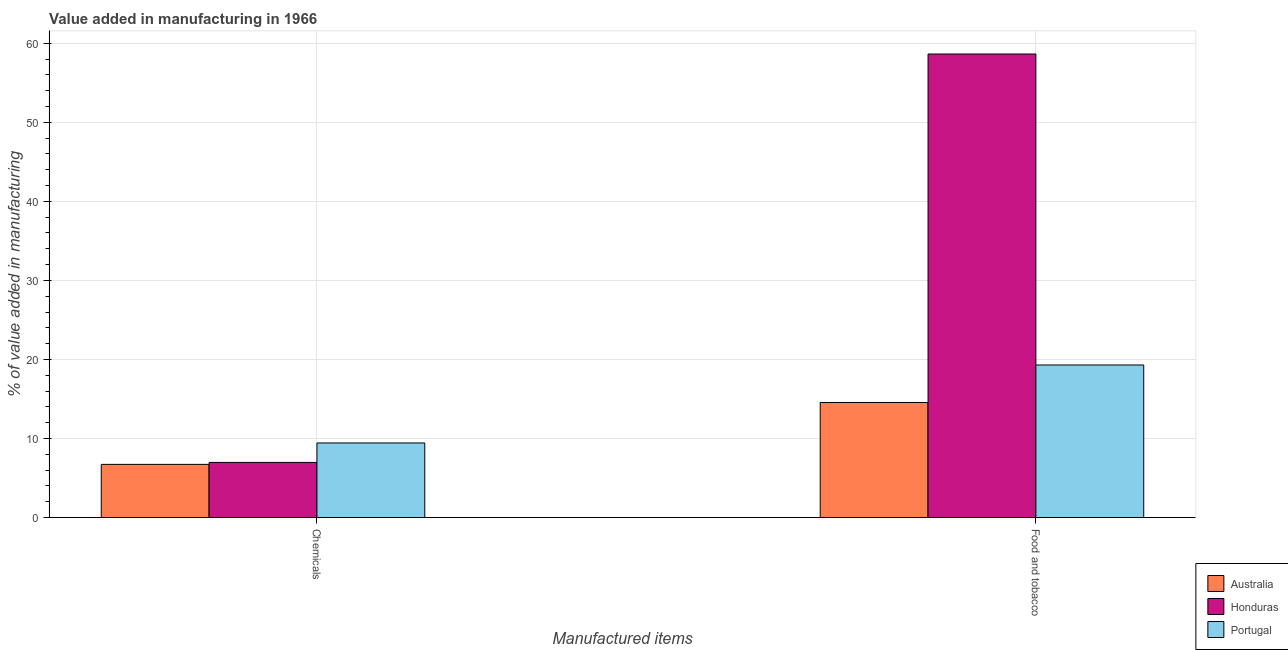How many groups of bars are there?
Keep it short and to the point. 2. How many bars are there on the 1st tick from the right?
Your response must be concise. 3. What is the label of the 1st group of bars from the left?
Offer a terse response. Chemicals. What is the value added by manufacturing food and tobacco in Australia?
Give a very brief answer. 14.56. Across all countries, what is the maximum value added by  manufacturing chemicals?
Offer a terse response. 9.44. Across all countries, what is the minimum value added by  manufacturing chemicals?
Make the answer very short. 6.73. What is the total value added by manufacturing food and tobacco in the graph?
Your answer should be compact. 92.49. What is the difference between the value added by manufacturing food and tobacco in Honduras and that in Portugal?
Your answer should be compact. 39.34. What is the difference between the value added by  manufacturing chemicals in Honduras and the value added by manufacturing food and tobacco in Portugal?
Offer a terse response. -12.33. What is the average value added by  manufacturing chemicals per country?
Make the answer very short. 7.71. What is the difference between the value added by  manufacturing chemicals and value added by manufacturing food and tobacco in Australia?
Ensure brevity in your answer.  -7.83. In how many countries, is the value added by  manufacturing chemicals greater than 46 %?
Give a very brief answer. 0. What is the ratio of the value added by  manufacturing chemicals in Portugal to that in Honduras?
Give a very brief answer. 1.35. What does the 2nd bar from the left in Food and tobacco represents?
Offer a very short reply. Honduras. What does the 2nd bar from the right in Food and tobacco represents?
Provide a succinct answer. Honduras. How many bars are there?
Make the answer very short. 6. Are all the bars in the graph horizontal?
Give a very brief answer. No. How many countries are there in the graph?
Make the answer very short. 3. What is the difference between two consecutive major ticks on the Y-axis?
Ensure brevity in your answer.  10. How many legend labels are there?
Your answer should be compact. 3. What is the title of the graph?
Your response must be concise. Value added in manufacturing in 1966. Does "Micronesia" appear as one of the legend labels in the graph?
Provide a short and direct response. No. What is the label or title of the X-axis?
Offer a terse response. Manufactured items. What is the label or title of the Y-axis?
Give a very brief answer. % of value added in manufacturing. What is the % of value added in manufacturing of Australia in Chemicals?
Offer a terse response. 6.73. What is the % of value added in manufacturing in Honduras in Chemicals?
Your answer should be very brief. 6.97. What is the % of value added in manufacturing in Portugal in Chemicals?
Provide a succinct answer. 9.44. What is the % of value added in manufacturing in Australia in Food and tobacco?
Ensure brevity in your answer.  14.56. What is the % of value added in manufacturing in Honduras in Food and tobacco?
Your answer should be compact. 58.64. What is the % of value added in manufacturing of Portugal in Food and tobacco?
Offer a terse response. 19.3. Across all Manufactured items, what is the maximum % of value added in manufacturing in Australia?
Give a very brief answer. 14.56. Across all Manufactured items, what is the maximum % of value added in manufacturing in Honduras?
Keep it short and to the point. 58.64. Across all Manufactured items, what is the maximum % of value added in manufacturing of Portugal?
Your answer should be very brief. 19.3. Across all Manufactured items, what is the minimum % of value added in manufacturing of Australia?
Your response must be concise. 6.73. Across all Manufactured items, what is the minimum % of value added in manufacturing in Honduras?
Provide a succinct answer. 6.97. Across all Manufactured items, what is the minimum % of value added in manufacturing in Portugal?
Offer a very short reply. 9.44. What is the total % of value added in manufacturing in Australia in the graph?
Offer a very short reply. 21.28. What is the total % of value added in manufacturing in Honduras in the graph?
Provide a succinct answer. 65.61. What is the total % of value added in manufacturing in Portugal in the graph?
Make the answer very short. 28.74. What is the difference between the % of value added in manufacturing of Australia in Chemicals and that in Food and tobacco?
Your answer should be compact. -7.83. What is the difference between the % of value added in manufacturing in Honduras in Chemicals and that in Food and tobacco?
Keep it short and to the point. -51.66. What is the difference between the % of value added in manufacturing in Portugal in Chemicals and that in Food and tobacco?
Ensure brevity in your answer.  -9.86. What is the difference between the % of value added in manufacturing in Australia in Chemicals and the % of value added in manufacturing in Honduras in Food and tobacco?
Offer a very short reply. -51.91. What is the difference between the % of value added in manufacturing in Australia in Chemicals and the % of value added in manufacturing in Portugal in Food and tobacco?
Your response must be concise. -12.57. What is the difference between the % of value added in manufacturing of Honduras in Chemicals and the % of value added in manufacturing of Portugal in Food and tobacco?
Keep it short and to the point. -12.33. What is the average % of value added in manufacturing of Australia per Manufactured items?
Offer a terse response. 10.64. What is the average % of value added in manufacturing of Honduras per Manufactured items?
Your answer should be very brief. 32.8. What is the average % of value added in manufacturing in Portugal per Manufactured items?
Keep it short and to the point. 14.37. What is the difference between the % of value added in manufacturing of Australia and % of value added in manufacturing of Honduras in Chemicals?
Your response must be concise. -0.25. What is the difference between the % of value added in manufacturing of Australia and % of value added in manufacturing of Portugal in Chemicals?
Your answer should be compact. -2.71. What is the difference between the % of value added in manufacturing in Honduras and % of value added in manufacturing in Portugal in Chemicals?
Make the answer very short. -2.46. What is the difference between the % of value added in manufacturing in Australia and % of value added in manufacturing in Honduras in Food and tobacco?
Your answer should be compact. -44.08. What is the difference between the % of value added in manufacturing in Australia and % of value added in manufacturing in Portugal in Food and tobacco?
Ensure brevity in your answer.  -4.74. What is the difference between the % of value added in manufacturing of Honduras and % of value added in manufacturing of Portugal in Food and tobacco?
Make the answer very short. 39.34. What is the ratio of the % of value added in manufacturing of Australia in Chemicals to that in Food and tobacco?
Offer a very short reply. 0.46. What is the ratio of the % of value added in manufacturing of Honduras in Chemicals to that in Food and tobacco?
Offer a very short reply. 0.12. What is the ratio of the % of value added in manufacturing in Portugal in Chemicals to that in Food and tobacco?
Your response must be concise. 0.49. What is the difference between the highest and the second highest % of value added in manufacturing of Australia?
Give a very brief answer. 7.83. What is the difference between the highest and the second highest % of value added in manufacturing in Honduras?
Keep it short and to the point. 51.66. What is the difference between the highest and the second highest % of value added in manufacturing of Portugal?
Offer a very short reply. 9.86. What is the difference between the highest and the lowest % of value added in manufacturing of Australia?
Your response must be concise. 7.83. What is the difference between the highest and the lowest % of value added in manufacturing of Honduras?
Offer a terse response. 51.66. What is the difference between the highest and the lowest % of value added in manufacturing in Portugal?
Offer a terse response. 9.86. 